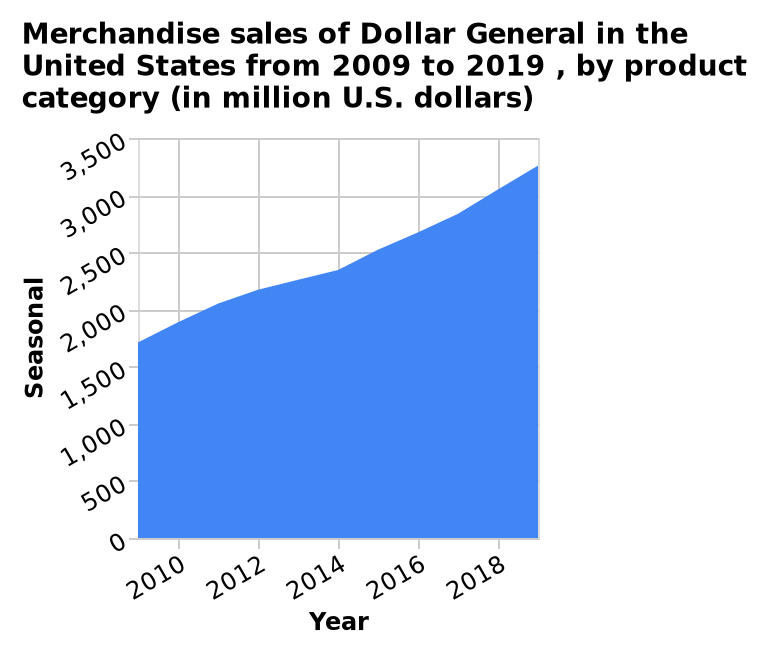<image>
What is the earliest year represented on the x-axis of the merchandise sales graph?  The earliest year represented on the x-axis is 2010. 